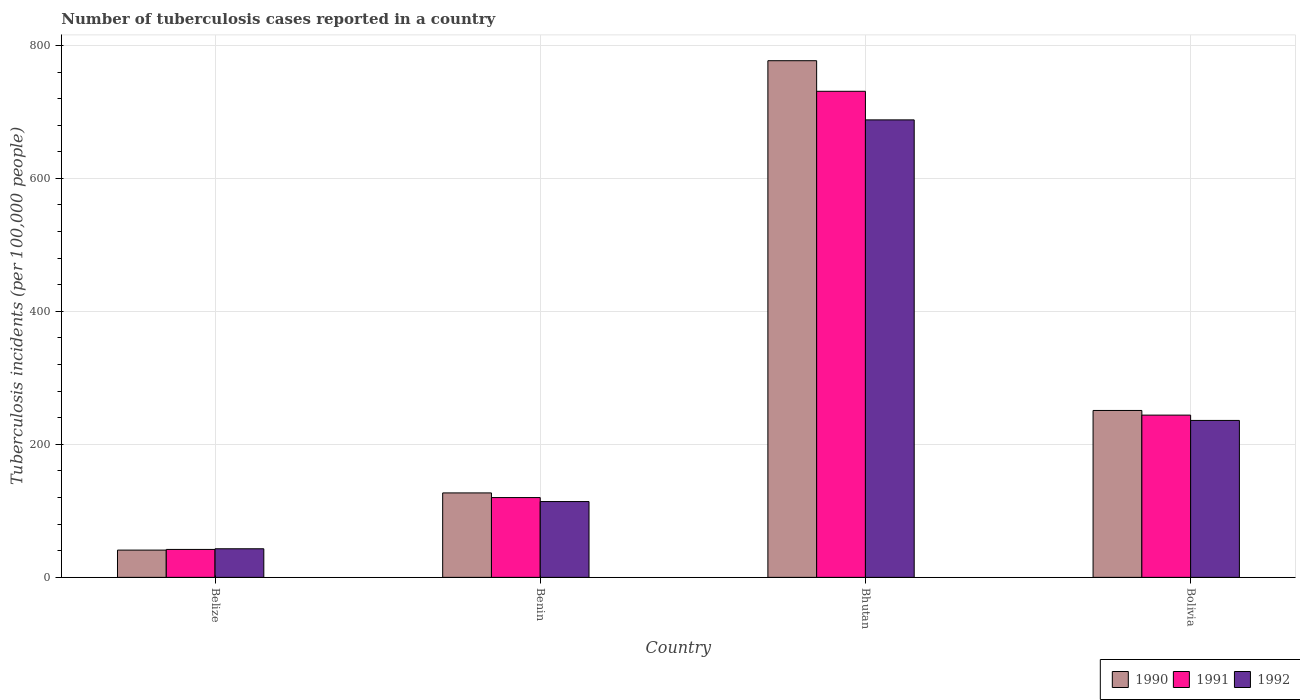How many bars are there on the 3rd tick from the right?
Offer a terse response. 3. What is the label of the 4th group of bars from the left?
Provide a short and direct response. Bolivia. What is the number of tuberculosis cases reported in in 1992 in Bhutan?
Your response must be concise. 688. Across all countries, what is the maximum number of tuberculosis cases reported in in 1990?
Keep it short and to the point. 777. In which country was the number of tuberculosis cases reported in in 1992 maximum?
Offer a very short reply. Bhutan. In which country was the number of tuberculosis cases reported in in 1991 minimum?
Offer a very short reply. Belize. What is the total number of tuberculosis cases reported in in 1991 in the graph?
Make the answer very short. 1137. What is the difference between the number of tuberculosis cases reported in in 1990 in Belize and that in Bolivia?
Keep it short and to the point. -210. What is the difference between the number of tuberculosis cases reported in in 1992 in Belize and the number of tuberculosis cases reported in in 1991 in Benin?
Your answer should be very brief. -77. What is the average number of tuberculosis cases reported in in 1992 per country?
Your answer should be compact. 270.25. What is the difference between the number of tuberculosis cases reported in of/in 1990 and number of tuberculosis cases reported in of/in 1991 in Bhutan?
Provide a short and direct response. 46. In how many countries, is the number of tuberculosis cases reported in in 1990 greater than 600?
Ensure brevity in your answer.  1. What is the ratio of the number of tuberculosis cases reported in in 1990 in Belize to that in Bolivia?
Offer a very short reply. 0.16. Is the difference between the number of tuberculosis cases reported in in 1990 in Benin and Bhutan greater than the difference between the number of tuberculosis cases reported in in 1991 in Benin and Bhutan?
Ensure brevity in your answer.  No. What is the difference between the highest and the second highest number of tuberculosis cases reported in in 1990?
Offer a terse response. 526. What is the difference between the highest and the lowest number of tuberculosis cases reported in in 1992?
Make the answer very short. 645. Is the sum of the number of tuberculosis cases reported in in 1992 in Belize and Bolivia greater than the maximum number of tuberculosis cases reported in in 1991 across all countries?
Offer a very short reply. No. What does the 3rd bar from the right in Belize represents?
Give a very brief answer. 1990. Is it the case that in every country, the sum of the number of tuberculosis cases reported in in 1991 and number of tuberculosis cases reported in in 1992 is greater than the number of tuberculosis cases reported in in 1990?
Provide a succinct answer. Yes. How many bars are there?
Offer a very short reply. 12. Are all the bars in the graph horizontal?
Offer a terse response. No. What is the difference between two consecutive major ticks on the Y-axis?
Your response must be concise. 200. Does the graph contain grids?
Ensure brevity in your answer.  Yes. What is the title of the graph?
Your answer should be compact. Number of tuberculosis cases reported in a country. Does "1974" appear as one of the legend labels in the graph?
Offer a very short reply. No. What is the label or title of the Y-axis?
Keep it short and to the point. Tuberculosis incidents (per 100,0 people). What is the Tuberculosis incidents (per 100,000 people) in 1990 in Belize?
Ensure brevity in your answer.  41. What is the Tuberculosis incidents (per 100,000 people) in 1992 in Belize?
Offer a very short reply. 43. What is the Tuberculosis incidents (per 100,000 people) in 1990 in Benin?
Your response must be concise. 127. What is the Tuberculosis incidents (per 100,000 people) of 1991 in Benin?
Make the answer very short. 120. What is the Tuberculosis incidents (per 100,000 people) of 1992 in Benin?
Provide a short and direct response. 114. What is the Tuberculosis incidents (per 100,000 people) in 1990 in Bhutan?
Offer a terse response. 777. What is the Tuberculosis incidents (per 100,000 people) of 1991 in Bhutan?
Keep it short and to the point. 731. What is the Tuberculosis incidents (per 100,000 people) of 1992 in Bhutan?
Make the answer very short. 688. What is the Tuberculosis incidents (per 100,000 people) of 1990 in Bolivia?
Ensure brevity in your answer.  251. What is the Tuberculosis incidents (per 100,000 people) in 1991 in Bolivia?
Your response must be concise. 244. What is the Tuberculosis incidents (per 100,000 people) in 1992 in Bolivia?
Offer a terse response. 236. Across all countries, what is the maximum Tuberculosis incidents (per 100,000 people) in 1990?
Offer a very short reply. 777. Across all countries, what is the maximum Tuberculosis incidents (per 100,000 people) in 1991?
Offer a terse response. 731. Across all countries, what is the maximum Tuberculosis incidents (per 100,000 people) in 1992?
Ensure brevity in your answer.  688. Across all countries, what is the minimum Tuberculosis incidents (per 100,000 people) of 1991?
Your response must be concise. 42. Across all countries, what is the minimum Tuberculosis incidents (per 100,000 people) of 1992?
Provide a succinct answer. 43. What is the total Tuberculosis incidents (per 100,000 people) of 1990 in the graph?
Provide a short and direct response. 1196. What is the total Tuberculosis incidents (per 100,000 people) of 1991 in the graph?
Your answer should be very brief. 1137. What is the total Tuberculosis incidents (per 100,000 people) in 1992 in the graph?
Keep it short and to the point. 1081. What is the difference between the Tuberculosis incidents (per 100,000 people) of 1990 in Belize and that in Benin?
Keep it short and to the point. -86. What is the difference between the Tuberculosis incidents (per 100,000 people) in 1991 in Belize and that in Benin?
Your answer should be compact. -78. What is the difference between the Tuberculosis incidents (per 100,000 people) in 1992 in Belize and that in Benin?
Your answer should be compact. -71. What is the difference between the Tuberculosis incidents (per 100,000 people) of 1990 in Belize and that in Bhutan?
Provide a succinct answer. -736. What is the difference between the Tuberculosis incidents (per 100,000 people) in 1991 in Belize and that in Bhutan?
Provide a short and direct response. -689. What is the difference between the Tuberculosis incidents (per 100,000 people) in 1992 in Belize and that in Bhutan?
Provide a succinct answer. -645. What is the difference between the Tuberculosis incidents (per 100,000 people) of 1990 in Belize and that in Bolivia?
Offer a very short reply. -210. What is the difference between the Tuberculosis incidents (per 100,000 people) of 1991 in Belize and that in Bolivia?
Your answer should be compact. -202. What is the difference between the Tuberculosis incidents (per 100,000 people) of 1992 in Belize and that in Bolivia?
Your response must be concise. -193. What is the difference between the Tuberculosis incidents (per 100,000 people) in 1990 in Benin and that in Bhutan?
Ensure brevity in your answer.  -650. What is the difference between the Tuberculosis incidents (per 100,000 people) of 1991 in Benin and that in Bhutan?
Provide a short and direct response. -611. What is the difference between the Tuberculosis incidents (per 100,000 people) in 1992 in Benin and that in Bhutan?
Your response must be concise. -574. What is the difference between the Tuberculosis incidents (per 100,000 people) in 1990 in Benin and that in Bolivia?
Your answer should be compact. -124. What is the difference between the Tuberculosis incidents (per 100,000 people) in 1991 in Benin and that in Bolivia?
Provide a short and direct response. -124. What is the difference between the Tuberculosis incidents (per 100,000 people) in 1992 in Benin and that in Bolivia?
Provide a short and direct response. -122. What is the difference between the Tuberculosis incidents (per 100,000 people) of 1990 in Bhutan and that in Bolivia?
Your response must be concise. 526. What is the difference between the Tuberculosis incidents (per 100,000 people) in 1991 in Bhutan and that in Bolivia?
Offer a very short reply. 487. What is the difference between the Tuberculosis incidents (per 100,000 people) of 1992 in Bhutan and that in Bolivia?
Keep it short and to the point. 452. What is the difference between the Tuberculosis incidents (per 100,000 people) of 1990 in Belize and the Tuberculosis incidents (per 100,000 people) of 1991 in Benin?
Give a very brief answer. -79. What is the difference between the Tuberculosis incidents (per 100,000 people) of 1990 in Belize and the Tuberculosis incidents (per 100,000 people) of 1992 in Benin?
Your answer should be very brief. -73. What is the difference between the Tuberculosis incidents (per 100,000 people) in 1991 in Belize and the Tuberculosis incidents (per 100,000 people) in 1992 in Benin?
Make the answer very short. -72. What is the difference between the Tuberculosis incidents (per 100,000 people) in 1990 in Belize and the Tuberculosis incidents (per 100,000 people) in 1991 in Bhutan?
Your answer should be very brief. -690. What is the difference between the Tuberculosis incidents (per 100,000 people) of 1990 in Belize and the Tuberculosis incidents (per 100,000 people) of 1992 in Bhutan?
Your response must be concise. -647. What is the difference between the Tuberculosis incidents (per 100,000 people) in 1991 in Belize and the Tuberculosis incidents (per 100,000 people) in 1992 in Bhutan?
Make the answer very short. -646. What is the difference between the Tuberculosis incidents (per 100,000 people) of 1990 in Belize and the Tuberculosis incidents (per 100,000 people) of 1991 in Bolivia?
Ensure brevity in your answer.  -203. What is the difference between the Tuberculosis incidents (per 100,000 people) in 1990 in Belize and the Tuberculosis incidents (per 100,000 people) in 1992 in Bolivia?
Your answer should be compact. -195. What is the difference between the Tuberculosis incidents (per 100,000 people) of 1991 in Belize and the Tuberculosis incidents (per 100,000 people) of 1992 in Bolivia?
Your answer should be very brief. -194. What is the difference between the Tuberculosis incidents (per 100,000 people) of 1990 in Benin and the Tuberculosis incidents (per 100,000 people) of 1991 in Bhutan?
Offer a very short reply. -604. What is the difference between the Tuberculosis incidents (per 100,000 people) of 1990 in Benin and the Tuberculosis incidents (per 100,000 people) of 1992 in Bhutan?
Keep it short and to the point. -561. What is the difference between the Tuberculosis incidents (per 100,000 people) of 1991 in Benin and the Tuberculosis incidents (per 100,000 people) of 1992 in Bhutan?
Your answer should be compact. -568. What is the difference between the Tuberculosis incidents (per 100,000 people) in 1990 in Benin and the Tuberculosis incidents (per 100,000 people) in 1991 in Bolivia?
Your answer should be very brief. -117. What is the difference between the Tuberculosis incidents (per 100,000 people) of 1990 in Benin and the Tuberculosis incidents (per 100,000 people) of 1992 in Bolivia?
Offer a terse response. -109. What is the difference between the Tuberculosis incidents (per 100,000 people) in 1991 in Benin and the Tuberculosis incidents (per 100,000 people) in 1992 in Bolivia?
Give a very brief answer. -116. What is the difference between the Tuberculosis incidents (per 100,000 people) of 1990 in Bhutan and the Tuberculosis incidents (per 100,000 people) of 1991 in Bolivia?
Your answer should be compact. 533. What is the difference between the Tuberculosis incidents (per 100,000 people) in 1990 in Bhutan and the Tuberculosis incidents (per 100,000 people) in 1992 in Bolivia?
Offer a terse response. 541. What is the difference between the Tuberculosis incidents (per 100,000 people) in 1991 in Bhutan and the Tuberculosis incidents (per 100,000 people) in 1992 in Bolivia?
Offer a very short reply. 495. What is the average Tuberculosis incidents (per 100,000 people) in 1990 per country?
Make the answer very short. 299. What is the average Tuberculosis incidents (per 100,000 people) in 1991 per country?
Offer a very short reply. 284.25. What is the average Tuberculosis incidents (per 100,000 people) in 1992 per country?
Your answer should be compact. 270.25. What is the difference between the Tuberculosis incidents (per 100,000 people) of 1990 and Tuberculosis incidents (per 100,000 people) of 1992 in Belize?
Your answer should be very brief. -2. What is the difference between the Tuberculosis incidents (per 100,000 people) in 1990 and Tuberculosis incidents (per 100,000 people) in 1992 in Benin?
Ensure brevity in your answer.  13. What is the difference between the Tuberculosis incidents (per 100,000 people) in 1990 and Tuberculosis incidents (per 100,000 people) in 1991 in Bhutan?
Your answer should be compact. 46. What is the difference between the Tuberculosis incidents (per 100,000 people) in 1990 and Tuberculosis incidents (per 100,000 people) in 1992 in Bhutan?
Your response must be concise. 89. What is the difference between the Tuberculosis incidents (per 100,000 people) in 1990 and Tuberculosis incidents (per 100,000 people) in 1991 in Bolivia?
Your answer should be compact. 7. What is the ratio of the Tuberculosis incidents (per 100,000 people) of 1990 in Belize to that in Benin?
Make the answer very short. 0.32. What is the ratio of the Tuberculosis incidents (per 100,000 people) of 1991 in Belize to that in Benin?
Offer a very short reply. 0.35. What is the ratio of the Tuberculosis incidents (per 100,000 people) of 1992 in Belize to that in Benin?
Keep it short and to the point. 0.38. What is the ratio of the Tuberculosis incidents (per 100,000 people) of 1990 in Belize to that in Bhutan?
Your answer should be compact. 0.05. What is the ratio of the Tuberculosis incidents (per 100,000 people) of 1991 in Belize to that in Bhutan?
Your answer should be compact. 0.06. What is the ratio of the Tuberculosis incidents (per 100,000 people) of 1992 in Belize to that in Bhutan?
Your response must be concise. 0.06. What is the ratio of the Tuberculosis incidents (per 100,000 people) in 1990 in Belize to that in Bolivia?
Your answer should be very brief. 0.16. What is the ratio of the Tuberculosis incidents (per 100,000 people) of 1991 in Belize to that in Bolivia?
Provide a succinct answer. 0.17. What is the ratio of the Tuberculosis incidents (per 100,000 people) of 1992 in Belize to that in Bolivia?
Ensure brevity in your answer.  0.18. What is the ratio of the Tuberculosis incidents (per 100,000 people) of 1990 in Benin to that in Bhutan?
Your answer should be compact. 0.16. What is the ratio of the Tuberculosis incidents (per 100,000 people) in 1991 in Benin to that in Bhutan?
Your answer should be very brief. 0.16. What is the ratio of the Tuberculosis incidents (per 100,000 people) of 1992 in Benin to that in Bhutan?
Offer a terse response. 0.17. What is the ratio of the Tuberculosis incidents (per 100,000 people) in 1990 in Benin to that in Bolivia?
Give a very brief answer. 0.51. What is the ratio of the Tuberculosis incidents (per 100,000 people) of 1991 in Benin to that in Bolivia?
Provide a short and direct response. 0.49. What is the ratio of the Tuberculosis incidents (per 100,000 people) of 1992 in Benin to that in Bolivia?
Offer a terse response. 0.48. What is the ratio of the Tuberculosis incidents (per 100,000 people) of 1990 in Bhutan to that in Bolivia?
Keep it short and to the point. 3.1. What is the ratio of the Tuberculosis incidents (per 100,000 people) in 1991 in Bhutan to that in Bolivia?
Ensure brevity in your answer.  3. What is the ratio of the Tuberculosis incidents (per 100,000 people) of 1992 in Bhutan to that in Bolivia?
Your answer should be compact. 2.92. What is the difference between the highest and the second highest Tuberculosis incidents (per 100,000 people) in 1990?
Offer a very short reply. 526. What is the difference between the highest and the second highest Tuberculosis incidents (per 100,000 people) in 1991?
Give a very brief answer. 487. What is the difference between the highest and the second highest Tuberculosis incidents (per 100,000 people) of 1992?
Keep it short and to the point. 452. What is the difference between the highest and the lowest Tuberculosis incidents (per 100,000 people) of 1990?
Offer a terse response. 736. What is the difference between the highest and the lowest Tuberculosis incidents (per 100,000 people) in 1991?
Your answer should be very brief. 689. What is the difference between the highest and the lowest Tuberculosis incidents (per 100,000 people) of 1992?
Provide a succinct answer. 645. 